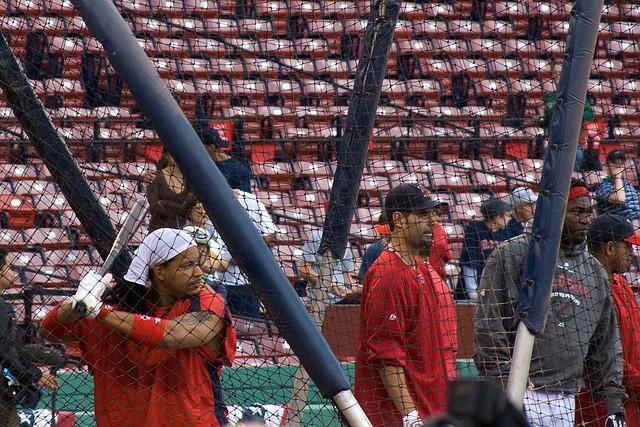Which base ball sport equipment is made up with maple wood?
Pick the right solution, then justify: 'Answer: answer
Rationale: rationale.'
Options: Bat, ball, net, cap. Answer: bat.
Rationale: The man is using a stick to hot the ball. 